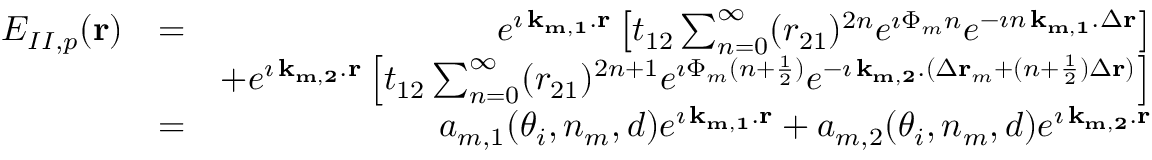Convert formula to latex. <formula><loc_0><loc_0><loc_500><loc_500>\begin{array} { r l r } { E _ { I I , p } ( { r } ) } & { = } & { e ^ { \imath \, { k _ { m , 1 } } . { r } } \left [ t _ { 1 2 } \sum _ { n = 0 } ^ { \infty } ( r _ { 2 1 } ) ^ { 2 n } e ^ { \imath \Phi _ { m } n } e ^ { - \imath n \, { k _ { m , 1 } } . \Delta { r } } \right ] } \\ & { + e ^ { \imath \, { k _ { m , 2 } } . { r } } \left [ t _ { 1 2 } \sum _ { n = 0 } ^ { \infty } ( r _ { 2 1 } ) ^ { 2 n + 1 } e ^ { \imath \Phi _ { m } ( n + \frac { 1 } { 2 } ) } e ^ { - \imath \, { k _ { m , 2 } } . ( \Delta { r } _ { m } + ( n + \frac { 1 } { 2 } ) \Delta { r } ) } \right ] } \\ & { = } & { a _ { m , 1 } ( \theta _ { i } , n _ { m } , d ) e ^ { \imath \, { k _ { m , 1 } } . { r } } + a _ { m , 2 } ( \theta _ { i } , n _ { m } , d ) e ^ { \imath \, { k _ { m , 2 } } . { r } } } \end{array}</formula> 